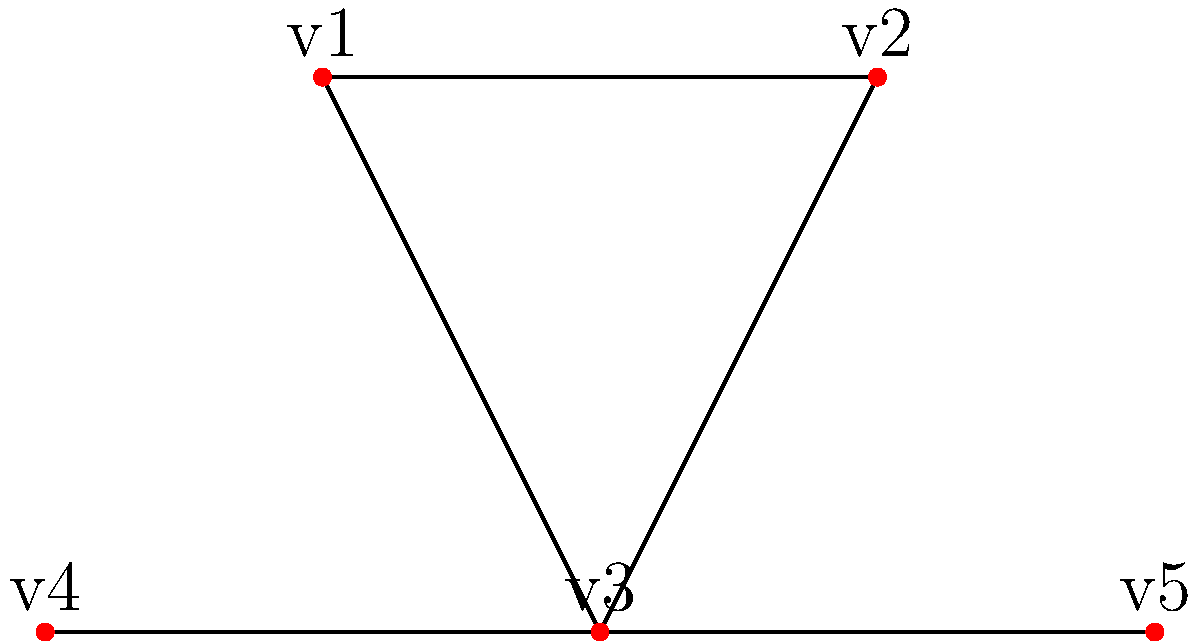In the given undirected graph, how many bridges are there? A bridge is defined as an edge whose removal would disconnect the graph into two separate components. Let's approach this step-by-step:

1) First, we need to understand what a bridge is. A bridge is an edge that, if removed, would increase the number of connected components in the graph.

2) Now, let's examine each edge:

   a) Edge v1-v2: If removed, the graph remains connected. Not a bridge.
   b) Edge v1-v3: If removed, the graph remains connected. Not a bridge.
   c) Edge v2-v3: If removed, the graph remains connected. Not a bridge.
   d) Edge v3-v4: If removed, v4 becomes isolated. This is a bridge.
   e) Edge v3-v5: If removed, v5 becomes isolated. This is a bridge.

3) To verify, we can use the following property: In a connected graph, an edge is a bridge if and only if it's not part of any cycle.

4) We can see that edges v3-v4 and v3-v5 are not part of any cycle, while the other edges form a cycle (v1-v2-v3-v1).

5) Therefore, there are two bridges in this graph: v3-v4 and v3-v5.
Answer: 2 